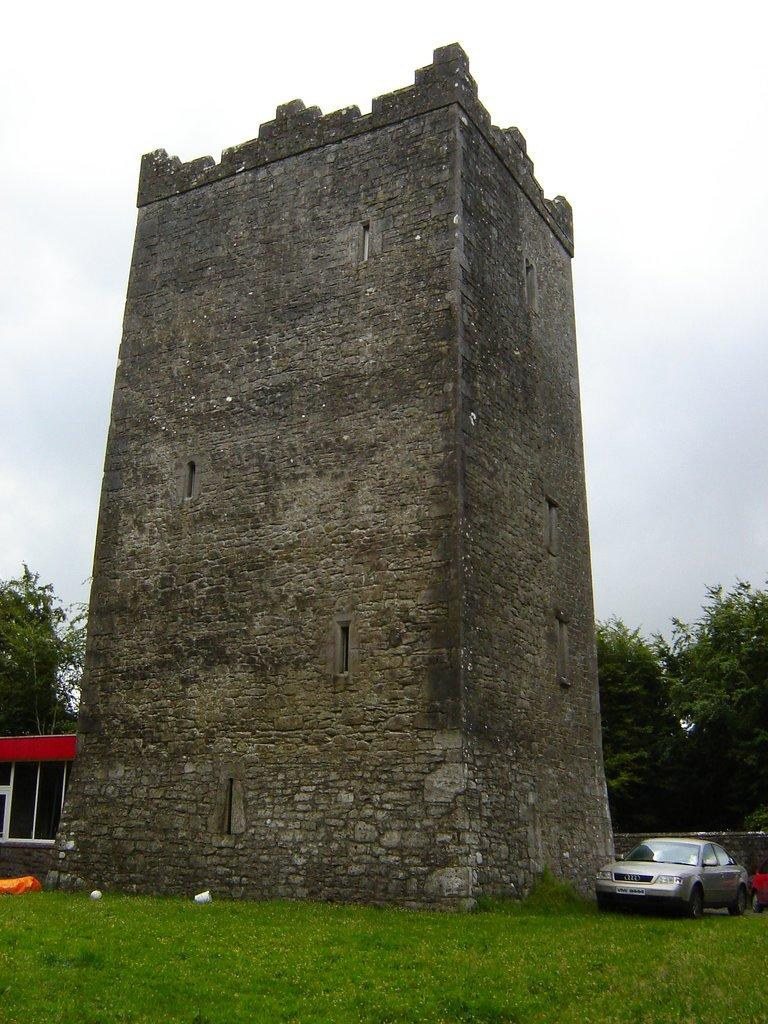What type of structure is located in the center of the image? There is an old building in the center of the image. What type of vegetation can be seen in the image? There are trees in the image. What type of small structure is present in the image? There is a shed in the image. What type of transportation can be seen in the image? There are vehicles in the image. What other objects are present on the ground in the image? There are other objects on the ground in the image. What is visible at the top of the image? The sky is visible at the top of the image. What type of skirt is hanging from the tree in the image? There is no skirt hanging from the tree in the image; only trees and other objects are present. 